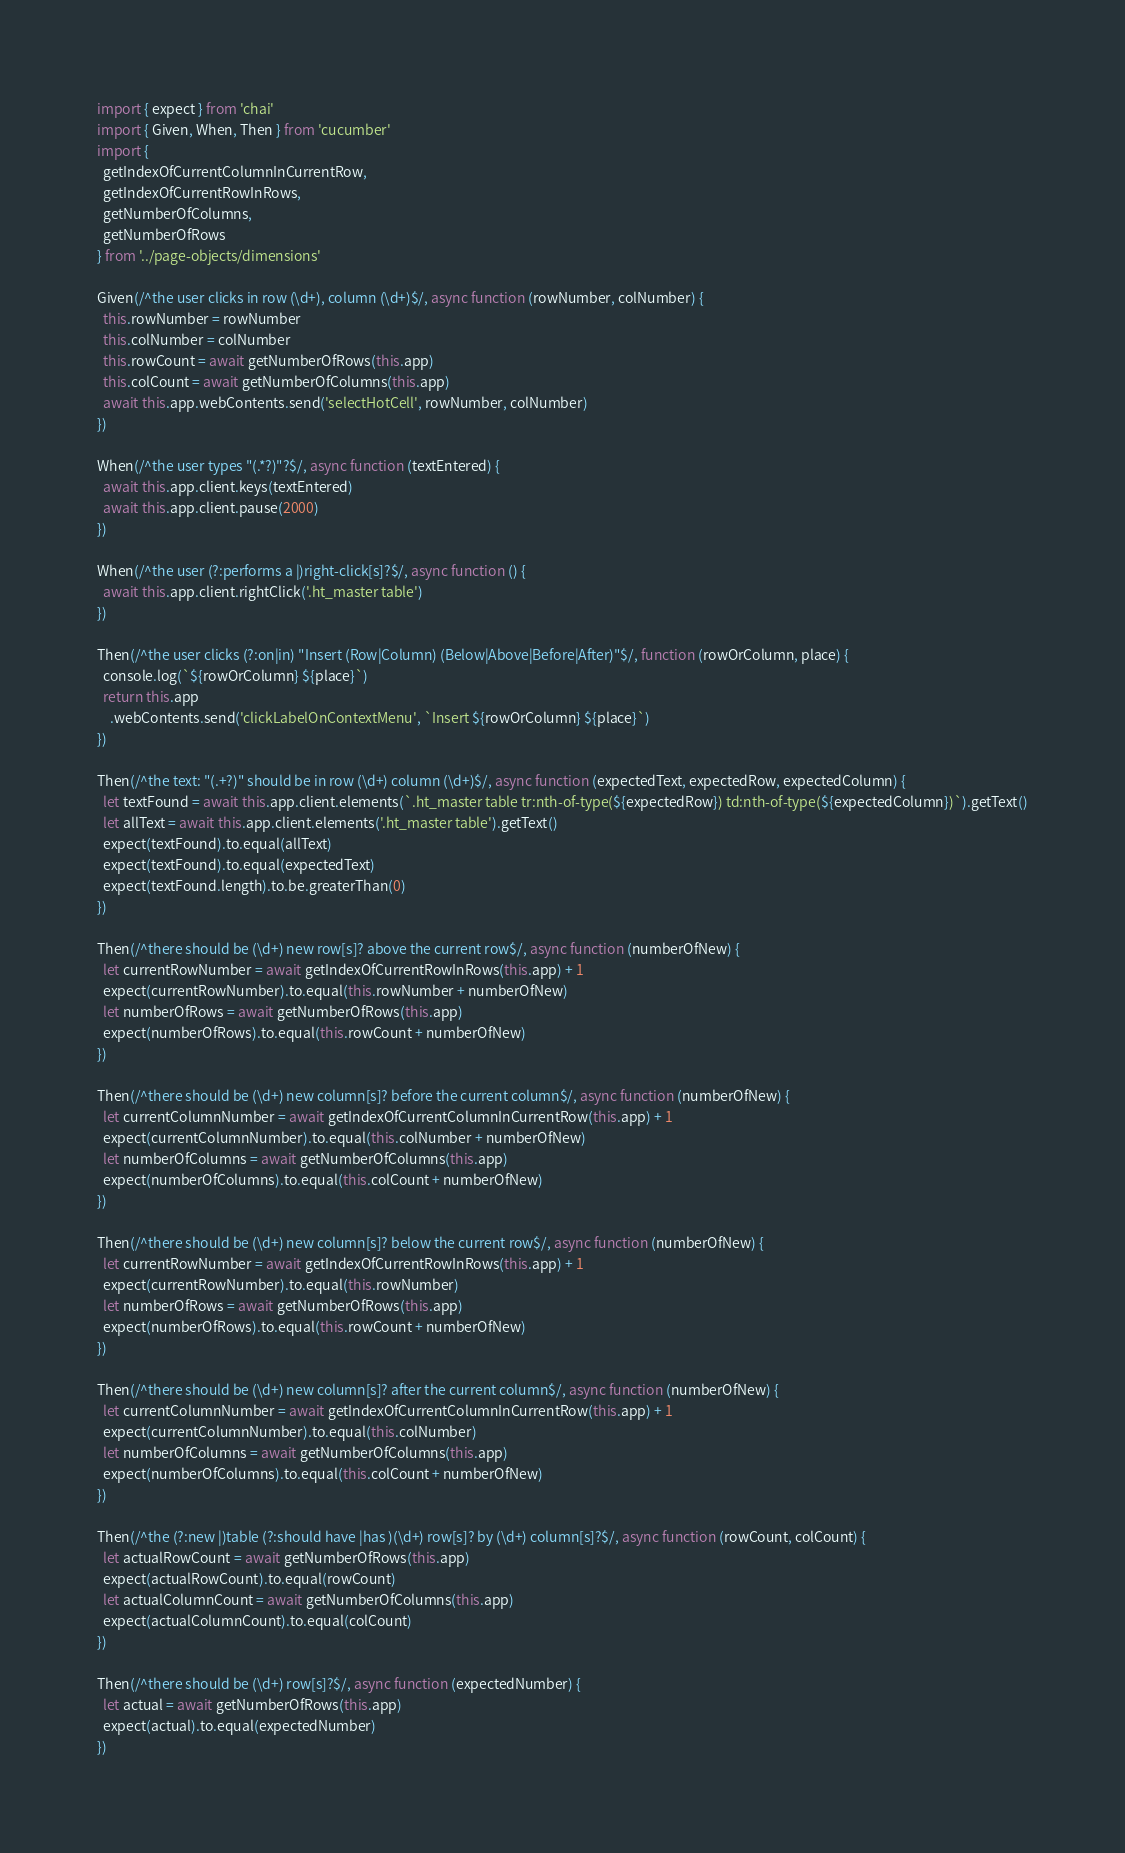Convert code to text. <code><loc_0><loc_0><loc_500><loc_500><_JavaScript_>import { expect } from 'chai'
import { Given, When, Then } from 'cucumber'
import {
  getIndexOfCurrentColumnInCurrentRow,
  getIndexOfCurrentRowInRows,
  getNumberOfColumns,
  getNumberOfRows
} from '../page-objects/dimensions'

Given(/^the user clicks in row (\d+), column (\d+)$/, async function (rowNumber, colNumber) {
  this.rowNumber = rowNumber
  this.colNumber = colNumber
  this.rowCount = await getNumberOfRows(this.app)
  this.colCount = await getNumberOfColumns(this.app)
  await this.app.webContents.send('selectHotCell', rowNumber, colNumber)
})

When(/^the user types "(.*?)"?$/, async function (textEntered) {
  await this.app.client.keys(textEntered)
  await this.app.client.pause(2000)
})

When(/^the user (?:performs a |)right-click[s]?$/, async function () {
  await this.app.client.rightClick('.ht_master table')
})

Then(/^the user clicks (?:on|in) "Insert (Row|Column) (Below|Above|Before|After)"$/, function (rowOrColumn, place) {
  console.log(`${rowOrColumn} ${place}`)
  return this.app
    .webContents.send('clickLabelOnContextMenu', `Insert ${rowOrColumn} ${place}`)
})

Then(/^the text: "(.+?)" should be in row (\d+) column (\d+)$/, async function (expectedText, expectedRow, expectedColumn) {
  let textFound = await this.app.client.elements(`.ht_master table tr:nth-of-type(${expectedRow}) td:nth-of-type(${expectedColumn})`).getText()
  let allText = await this.app.client.elements('.ht_master table').getText()
  expect(textFound).to.equal(allText)
  expect(textFound).to.equal(expectedText)
  expect(textFound.length).to.be.greaterThan(0)
})

Then(/^there should be (\d+) new row[s]? above the current row$/, async function (numberOfNew) {
  let currentRowNumber = await getIndexOfCurrentRowInRows(this.app) + 1
  expect(currentRowNumber).to.equal(this.rowNumber + numberOfNew)
  let numberOfRows = await getNumberOfRows(this.app)
  expect(numberOfRows).to.equal(this.rowCount + numberOfNew)
})

Then(/^there should be (\d+) new column[s]? before the current column$/, async function (numberOfNew) {
  let currentColumnNumber = await getIndexOfCurrentColumnInCurrentRow(this.app) + 1
  expect(currentColumnNumber).to.equal(this.colNumber + numberOfNew)
  let numberOfColumns = await getNumberOfColumns(this.app)
  expect(numberOfColumns).to.equal(this.colCount + numberOfNew)
})

Then(/^there should be (\d+) new column[s]? below the current row$/, async function (numberOfNew) {
  let currentRowNumber = await getIndexOfCurrentRowInRows(this.app) + 1
  expect(currentRowNumber).to.equal(this.rowNumber)
  let numberOfRows = await getNumberOfRows(this.app)
  expect(numberOfRows).to.equal(this.rowCount + numberOfNew)
})

Then(/^there should be (\d+) new column[s]? after the current column$/, async function (numberOfNew) {
  let currentColumnNumber = await getIndexOfCurrentColumnInCurrentRow(this.app) + 1
  expect(currentColumnNumber).to.equal(this.colNumber)
  let numberOfColumns = await getNumberOfColumns(this.app)
  expect(numberOfColumns).to.equal(this.colCount + numberOfNew)
})

Then(/^the (?:new |)table (?:should have |has )(\d+) row[s]? by (\d+) column[s]?$/, async function (rowCount, colCount) {
  let actualRowCount = await getNumberOfRows(this.app)
  expect(actualRowCount).to.equal(rowCount)
  let actualColumnCount = await getNumberOfColumns(this.app)
  expect(actualColumnCount).to.equal(colCount)
})

Then(/^there should be (\d+) row[s]?$/, async function (expectedNumber) {
  let actual = await getNumberOfRows(this.app)
  expect(actual).to.equal(expectedNumber)
})
</code> 